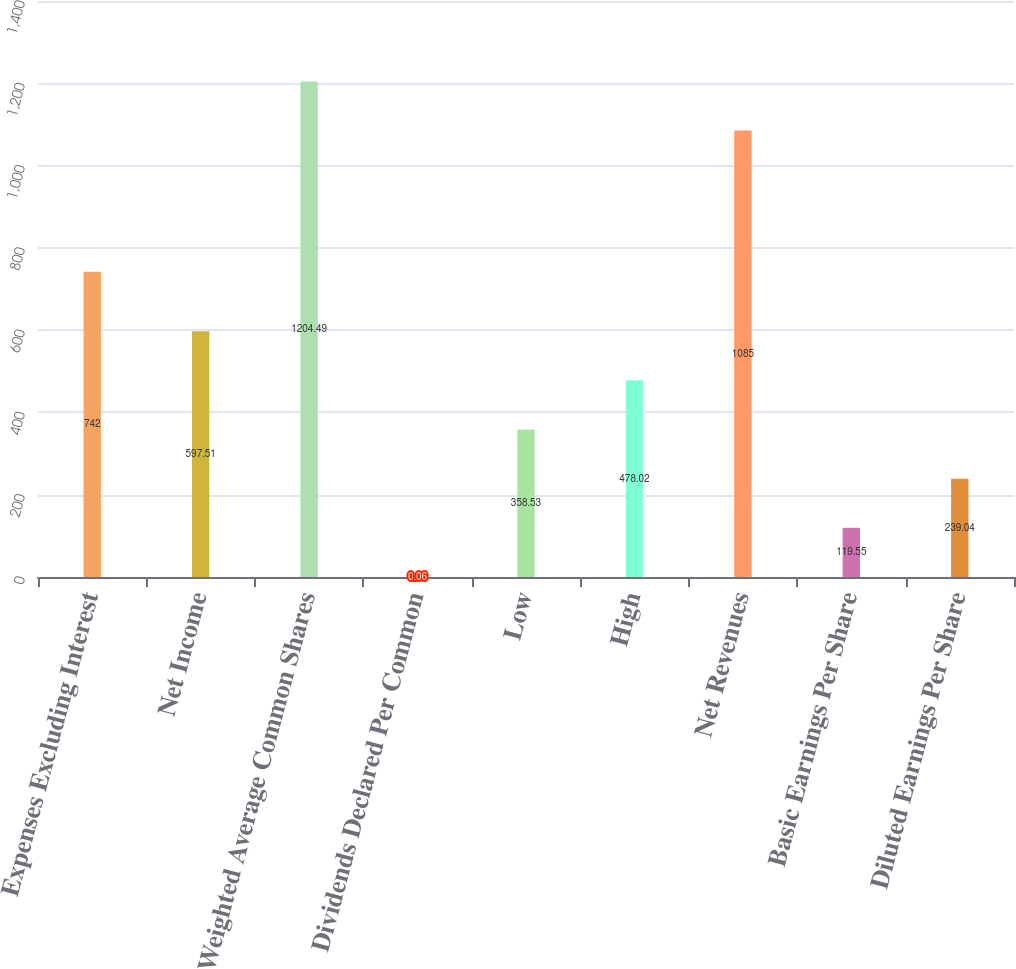Convert chart to OTSL. <chart><loc_0><loc_0><loc_500><loc_500><bar_chart><fcel>Expenses Excluding Interest<fcel>Net Income<fcel>Weighted Average Common Shares<fcel>Dividends Declared Per Common<fcel>Low<fcel>High<fcel>Net Revenues<fcel>Basic Earnings Per Share<fcel>Diluted Earnings Per Share<nl><fcel>742<fcel>597.51<fcel>1204.49<fcel>0.06<fcel>358.53<fcel>478.02<fcel>1085<fcel>119.55<fcel>239.04<nl></chart> 